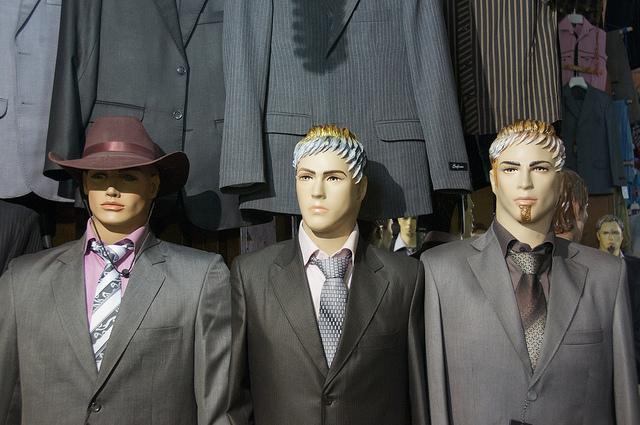How many hats?
Give a very brief answer. 1. How many ties are there?
Give a very brief answer. 3. How many people can be seen?
Give a very brief answer. 2. 